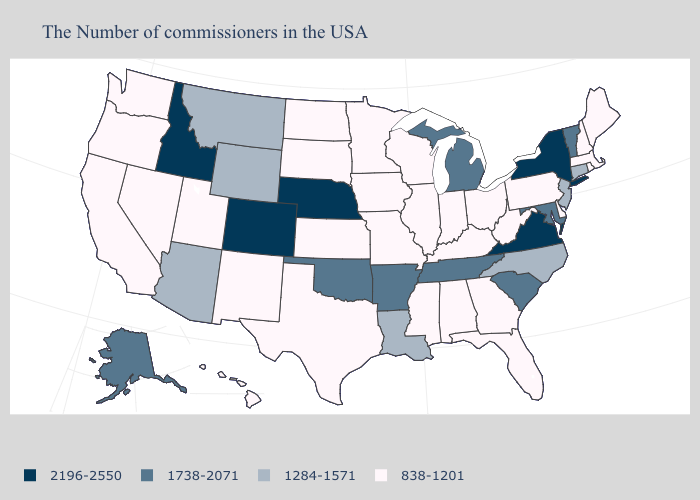What is the value of Idaho?
Write a very short answer. 2196-2550. Name the states that have a value in the range 1738-2071?
Quick response, please. Vermont, Maryland, South Carolina, Michigan, Tennessee, Arkansas, Oklahoma, Alaska. Does Colorado have the highest value in the West?
Concise answer only. Yes. Does the map have missing data?
Keep it brief. No. Name the states that have a value in the range 838-1201?
Give a very brief answer. Maine, Massachusetts, Rhode Island, New Hampshire, Delaware, Pennsylvania, West Virginia, Ohio, Florida, Georgia, Kentucky, Indiana, Alabama, Wisconsin, Illinois, Mississippi, Missouri, Minnesota, Iowa, Kansas, Texas, South Dakota, North Dakota, New Mexico, Utah, Nevada, California, Washington, Oregon, Hawaii. What is the value of Alabama?
Give a very brief answer. 838-1201. Name the states that have a value in the range 2196-2550?
Answer briefly. New York, Virginia, Nebraska, Colorado, Idaho. What is the value of Vermont?
Concise answer only. 1738-2071. Does the first symbol in the legend represent the smallest category?
Concise answer only. No. What is the value of New Jersey?
Write a very short answer. 1284-1571. Name the states that have a value in the range 838-1201?
Answer briefly. Maine, Massachusetts, Rhode Island, New Hampshire, Delaware, Pennsylvania, West Virginia, Ohio, Florida, Georgia, Kentucky, Indiana, Alabama, Wisconsin, Illinois, Mississippi, Missouri, Minnesota, Iowa, Kansas, Texas, South Dakota, North Dakota, New Mexico, Utah, Nevada, California, Washington, Oregon, Hawaii. Among the states that border Ohio , does Michigan have the highest value?
Concise answer only. Yes. What is the highest value in states that border Ohio?
Answer briefly. 1738-2071. Does Hawaii have the highest value in the USA?
Quick response, please. No. Does the first symbol in the legend represent the smallest category?
Give a very brief answer. No. 